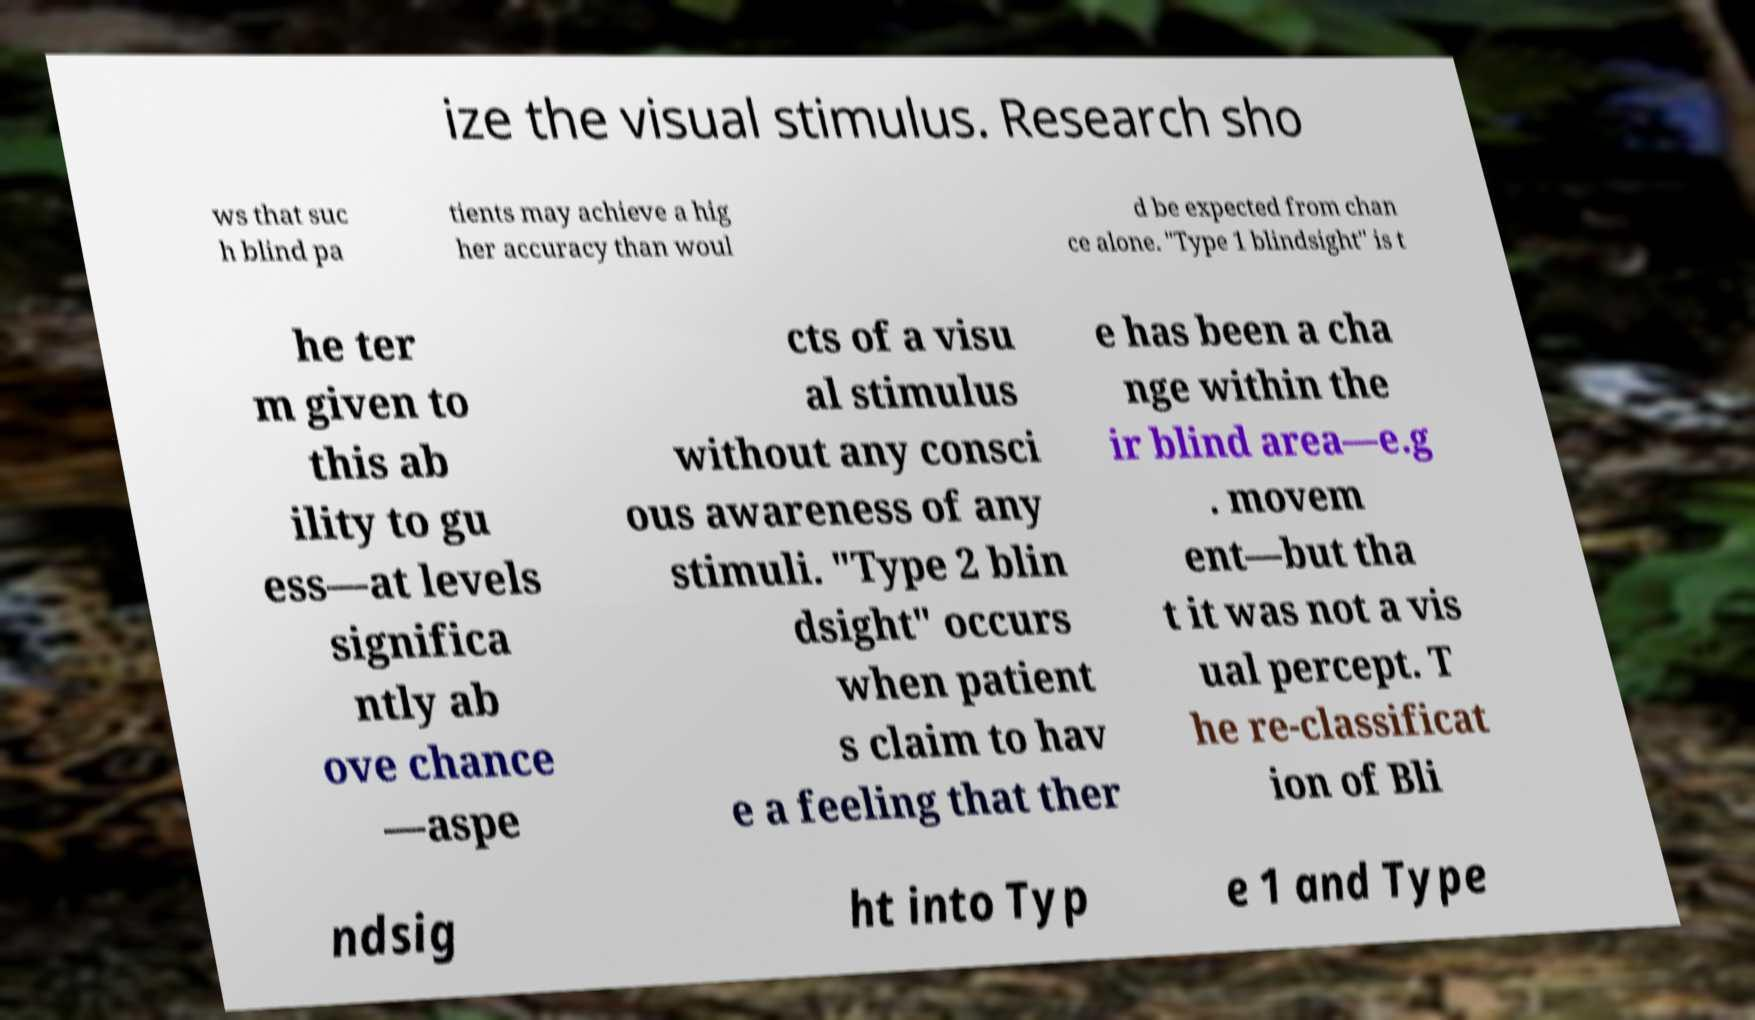For documentation purposes, I need the text within this image transcribed. Could you provide that? ize the visual stimulus. Research sho ws that suc h blind pa tients may achieve a hig her accuracy than woul d be expected from chan ce alone. "Type 1 blindsight" is t he ter m given to this ab ility to gu ess—at levels significa ntly ab ove chance —aspe cts of a visu al stimulus without any consci ous awareness of any stimuli. "Type 2 blin dsight" occurs when patient s claim to hav e a feeling that ther e has been a cha nge within the ir blind area—e.g . movem ent—but tha t it was not a vis ual percept. T he re-classificat ion of Bli ndsig ht into Typ e 1 and Type 